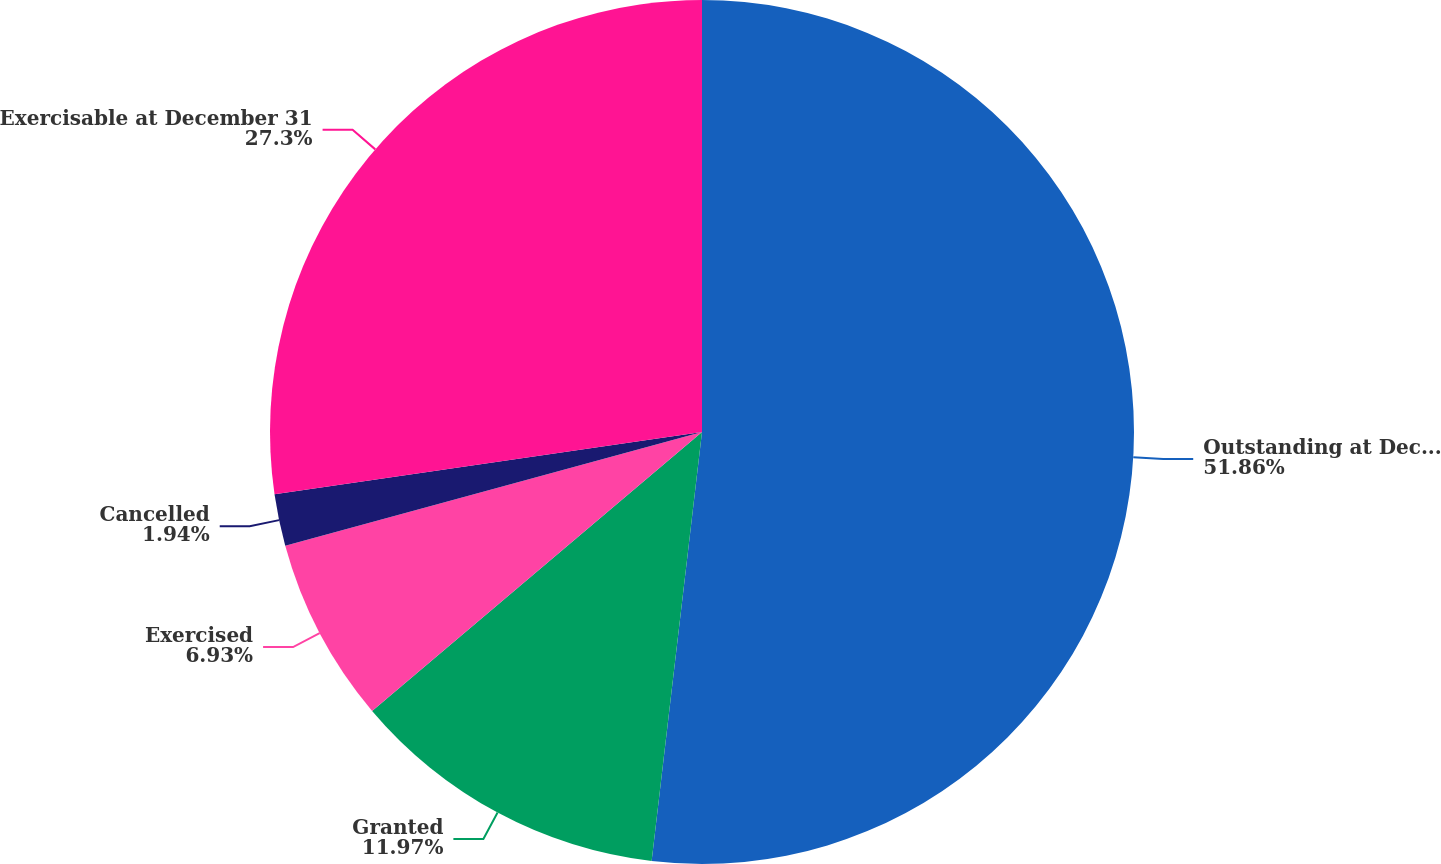<chart> <loc_0><loc_0><loc_500><loc_500><pie_chart><fcel>Outstanding at December 31<fcel>Granted<fcel>Exercised<fcel>Cancelled<fcel>Exercisable at December 31<nl><fcel>51.86%<fcel>11.97%<fcel>6.93%<fcel>1.94%<fcel>27.3%<nl></chart> 